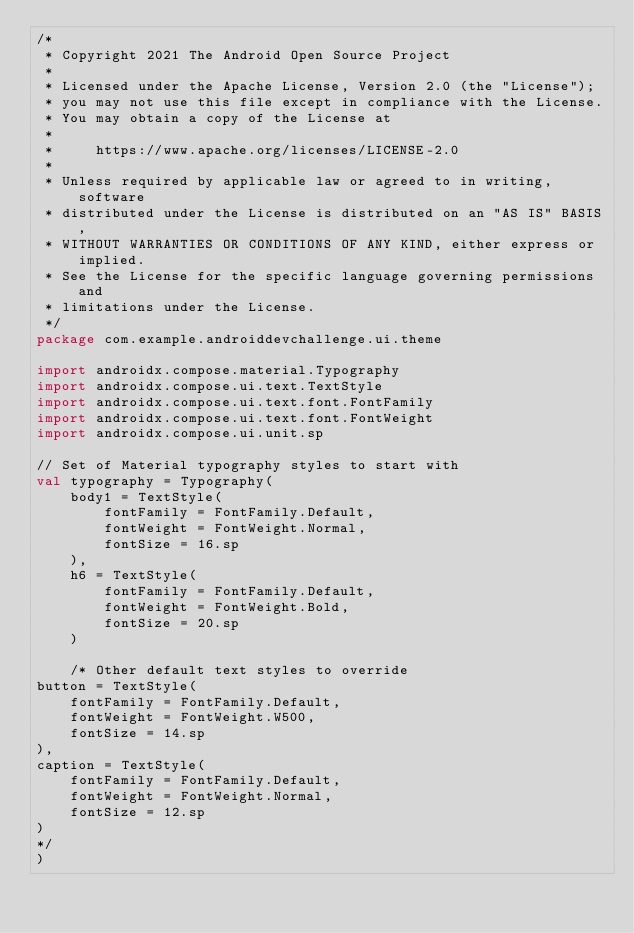Convert code to text. <code><loc_0><loc_0><loc_500><loc_500><_Kotlin_>/*
 * Copyright 2021 The Android Open Source Project
 *
 * Licensed under the Apache License, Version 2.0 (the "License");
 * you may not use this file except in compliance with the License.
 * You may obtain a copy of the License at
 *
 *     https://www.apache.org/licenses/LICENSE-2.0
 *
 * Unless required by applicable law or agreed to in writing, software
 * distributed under the License is distributed on an "AS IS" BASIS,
 * WITHOUT WARRANTIES OR CONDITIONS OF ANY KIND, either express or implied.
 * See the License for the specific language governing permissions and
 * limitations under the License.
 */
package com.example.androiddevchallenge.ui.theme

import androidx.compose.material.Typography
import androidx.compose.ui.text.TextStyle
import androidx.compose.ui.text.font.FontFamily
import androidx.compose.ui.text.font.FontWeight
import androidx.compose.ui.unit.sp

// Set of Material typography styles to start with
val typography = Typography(
    body1 = TextStyle(
        fontFamily = FontFamily.Default,
        fontWeight = FontWeight.Normal,
        fontSize = 16.sp
    ),
    h6 = TextStyle(
        fontFamily = FontFamily.Default,
        fontWeight = FontWeight.Bold,
        fontSize = 20.sp
    )

    /* Other default text styles to override
button = TextStyle(
    fontFamily = FontFamily.Default,
    fontWeight = FontWeight.W500,
    fontSize = 14.sp
),
caption = TextStyle(
    fontFamily = FontFamily.Default,
    fontWeight = FontWeight.Normal,
    fontSize = 12.sp
)
*/
)
</code> 